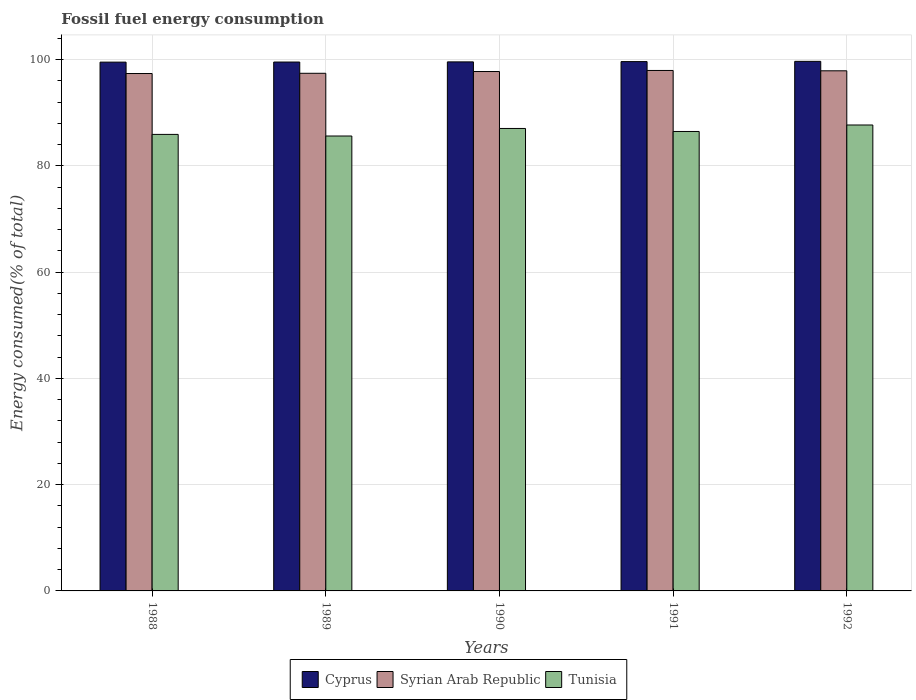How many groups of bars are there?
Your answer should be compact. 5. Are the number of bars per tick equal to the number of legend labels?
Make the answer very short. Yes. How many bars are there on the 5th tick from the left?
Provide a succinct answer. 3. What is the label of the 3rd group of bars from the left?
Keep it short and to the point. 1990. What is the percentage of energy consumed in Cyprus in 1989?
Your answer should be very brief. 99.52. Across all years, what is the maximum percentage of energy consumed in Cyprus?
Make the answer very short. 99.65. Across all years, what is the minimum percentage of energy consumed in Cyprus?
Your answer should be compact. 99.5. What is the total percentage of energy consumed in Tunisia in the graph?
Keep it short and to the point. 432.66. What is the difference between the percentage of energy consumed in Tunisia in 1988 and that in 1992?
Your response must be concise. -1.77. What is the difference between the percentage of energy consumed in Tunisia in 1992 and the percentage of energy consumed in Cyprus in 1991?
Provide a short and direct response. -11.93. What is the average percentage of energy consumed in Cyprus per year?
Keep it short and to the point. 99.57. In the year 1991, what is the difference between the percentage of energy consumed in Cyprus and percentage of energy consumed in Tunisia?
Ensure brevity in your answer.  13.15. What is the ratio of the percentage of energy consumed in Cyprus in 1989 to that in 1990?
Make the answer very short. 1. Is the difference between the percentage of energy consumed in Cyprus in 1991 and 1992 greater than the difference between the percentage of energy consumed in Tunisia in 1991 and 1992?
Keep it short and to the point. Yes. What is the difference between the highest and the second highest percentage of energy consumed in Tunisia?
Provide a short and direct response. 0.65. What is the difference between the highest and the lowest percentage of energy consumed in Tunisia?
Make the answer very short. 2.07. What does the 1st bar from the left in 1992 represents?
Make the answer very short. Cyprus. What does the 3rd bar from the right in 1992 represents?
Your answer should be very brief. Cyprus. Are all the bars in the graph horizontal?
Offer a very short reply. No. What is the difference between two consecutive major ticks on the Y-axis?
Your answer should be very brief. 20. Where does the legend appear in the graph?
Keep it short and to the point. Bottom center. How are the legend labels stacked?
Give a very brief answer. Horizontal. What is the title of the graph?
Offer a terse response. Fossil fuel energy consumption. Does "Vietnam" appear as one of the legend labels in the graph?
Offer a very short reply. No. What is the label or title of the Y-axis?
Provide a short and direct response. Energy consumed(% of total). What is the Energy consumed(% of total) of Cyprus in 1988?
Your response must be concise. 99.5. What is the Energy consumed(% of total) in Syrian Arab Republic in 1988?
Your answer should be very brief. 97.36. What is the Energy consumed(% of total) of Tunisia in 1988?
Your answer should be very brief. 85.9. What is the Energy consumed(% of total) of Cyprus in 1989?
Provide a short and direct response. 99.52. What is the Energy consumed(% of total) of Syrian Arab Republic in 1989?
Provide a succinct answer. 97.4. What is the Energy consumed(% of total) of Tunisia in 1989?
Make the answer very short. 85.6. What is the Energy consumed(% of total) of Cyprus in 1990?
Offer a very short reply. 99.55. What is the Energy consumed(% of total) in Syrian Arab Republic in 1990?
Give a very brief answer. 97.74. What is the Energy consumed(% of total) in Tunisia in 1990?
Your answer should be compact. 87.02. What is the Energy consumed(% of total) of Cyprus in 1991?
Offer a terse response. 99.6. What is the Energy consumed(% of total) in Syrian Arab Republic in 1991?
Offer a very short reply. 97.93. What is the Energy consumed(% of total) in Tunisia in 1991?
Give a very brief answer. 86.45. What is the Energy consumed(% of total) in Cyprus in 1992?
Provide a succinct answer. 99.65. What is the Energy consumed(% of total) of Syrian Arab Republic in 1992?
Make the answer very short. 97.87. What is the Energy consumed(% of total) of Tunisia in 1992?
Offer a terse response. 87.68. Across all years, what is the maximum Energy consumed(% of total) in Cyprus?
Offer a terse response. 99.65. Across all years, what is the maximum Energy consumed(% of total) in Syrian Arab Republic?
Your response must be concise. 97.93. Across all years, what is the maximum Energy consumed(% of total) of Tunisia?
Provide a succinct answer. 87.68. Across all years, what is the minimum Energy consumed(% of total) of Cyprus?
Make the answer very short. 99.5. Across all years, what is the minimum Energy consumed(% of total) of Syrian Arab Republic?
Your answer should be very brief. 97.36. Across all years, what is the minimum Energy consumed(% of total) of Tunisia?
Provide a short and direct response. 85.6. What is the total Energy consumed(% of total) in Cyprus in the graph?
Provide a short and direct response. 497.83. What is the total Energy consumed(% of total) in Syrian Arab Republic in the graph?
Offer a very short reply. 488.31. What is the total Energy consumed(% of total) of Tunisia in the graph?
Offer a terse response. 432.66. What is the difference between the Energy consumed(% of total) of Cyprus in 1988 and that in 1989?
Provide a short and direct response. -0.02. What is the difference between the Energy consumed(% of total) in Syrian Arab Republic in 1988 and that in 1989?
Your answer should be compact. -0.05. What is the difference between the Energy consumed(% of total) in Tunisia in 1988 and that in 1989?
Your answer should be very brief. 0.3. What is the difference between the Energy consumed(% of total) in Cyprus in 1988 and that in 1990?
Your answer should be very brief. -0.05. What is the difference between the Energy consumed(% of total) of Syrian Arab Republic in 1988 and that in 1990?
Offer a terse response. -0.38. What is the difference between the Energy consumed(% of total) in Tunisia in 1988 and that in 1990?
Make the answer very short. -1.12. What is the difference between the Energy consumed(% of total) in Cyprus in 1988 and that in 1991?
Your response must be concise. -0.1. What is the difference between the Energy consumed(% of total) in Syrian Arab Republic in 1988 and that in 1991?
Make the answer very short. -0.58. What is the difference between the Energy consumed(% of total) in Tunisia in 1988 and that in 1991?
Keep it short and to the point. -0.55. What is the difference between the Energy consumed(% of total) of Cyprus in 1988 and that in 1992?
Your answer should be compact. -0.15. What is the difference between the Energy consumed(% of total) of Syrian Arab Republic in 1988 and that in 1992?
Your response must be concise. -0.51. What is the difference between the Energy consumed(% of total) of Tunisia in 1988 and that in 1992?
Keep it short and to the point. -1.77. What is the difference between the Energy consumed(% of total) in Cyprus in 1989 and that in 1990?
Your answer should be compact. -0.03. What is the difference between the Energy consumed(% of total) of Syrian Arab Republic in 1989 and that in 1990?
Your answer should be compact. -0.33. What is the difference between the Energy consumed(% of total) in Tunisia in 1989 and that in 1990?
Ensure brevity in your answer.  -1.42. What is the difference between the Energy consumed(% of total) of Cyprus in 1989 and that in 1991?
Your answer should be compact. -0.08. What is the difference between the Energy consumed(% of total) in Syrian Arab Republic in 1989 and that in 1991?
Your answer should be very brief. -0.53. What is the difference between the Energy consumed(% of total) of Tunisia in 1989 and that in 1991?
Give a very brief answer. -0.85. What is the difference between the Energy consumed(% of total) of Cyprus in 1989 and that in 1992?
Make the answer very short. -0.13. What is the difference between the Energy consumed(% of total) in Syrian Arab Republic in 1989 and that in 1992?
Make the answer very short. -0.47. What is the difference between the Energy consumed(% of total) of Tunisia in 1989 and that in 1992?
Keep it short and to the point. -2.07. What is the difference between the Energy consumed(% of total) in Cyprus in 1990 and that in 1991?
Provide a succinct answer. -0.05. What is the difference between the Energy consumed(% of total) of Syrian Arab Republic in 1990 and that in 1991?
Your answer should be very brief. -0.2. What is the difference between the Energy consumed(% of total) of Tunisia in 1990 and that in 1991?
Keep it short and to the point. 0.57. What is the difference between the Energy consumed(% of total) of Cyprus in 1990 and that in 1992?
Your answer should be very brief. -0.1. What is the difference between the Energy consumed(% of total) in Syrian Arab Republic in 1990 and that in 1992?
Provide a succinct answer. -0.14. What is the difference between the Energy consumed(% of total) of Tunisia in 1990 and that in 1992?
Your answer should be very brief. -0.65. What is the difference between the Energy consumed(% of total) of Cyprus in 1991 and that in 1992?
Your answer should be very brief. -0.05. What is the difference between the Energy consumed(% of total) in Syrian Arab Republic in 1991 and that in 1992?
Give a very brief answer. 0.06. What is the difference between the Energy consumed(% of total) in Tunisia in 1991 and that in 1992?
Give a very brief answer. -1.22. What is the difference between the Energy consumed(% of total) of Cyprus in 1988 and the Energy consumed(% of total) of Syrian Arab Republic in 1989?
Keep it short and to the point. 2.1. What is the difference between the Energy consumed(% of total) in Cyprus in 1988 and the Energy consumed(% of total) in Tunisia in 1989?
Ensure brevity in your answer.  13.9. What is the difference between the Energy consumed(% of total) of Syrian Arab Republic in 1988 and the Energy consumed(% of total) of Tunisia in 1989?
Provide a short and direct response. 11.76. What is the difference between the Energy consumed(% of total) of Cyprus in 1988 and the Energy consumed(% of total) of Syrian Arab Republic in 1990?
Give a very brief answer. 1.77. What is the difference between the Energy consumed(% of total) of Cyprus in 1988 and the Energy consumed(% of total) of Tunisia in 1990?
Offer a terse response. 12.48. What is the difference between the Energy consumed(% of total) of Syrian Arab Republic in 1988 and the Energy consumed(% of total) of Tunisia in 1990?
Offer a terse response. 10.34. What is the difference between the Energy consumed(% of total) in Cyprus in 1988 and the Energy consumed(% of total) in Syrian Arab Republic in 1991?
Provide a short and direct response. 1.57. What is the difference between the Energy consumed(% of total) of Cyprus in 1988 and the Energy consumed(% of total) of Tunisia in 1991?
Your answer should be very brief. 13.05. What is the difference between the Energy consumed(% of total) of Syrian Arab Republic in 1988 and the Energy consumed(% of total) of Tunisia in 1991?
Your answer should be very brief. 10.91. What is the difference between the Energy consumed(% of total) of Cyprus in 1988 and the Energy consumed(% of total) of Syrian Arab Republic in 1992?
Ensure brevity in your answer.  1.63. What is the difference between the Energy consumed(% of total) in Cyprus in 1988 and the Energy consumed(% of total) in Tunisia in 1992?
Offer a terse response. 11.83. What is the difference between the Energy consumed(% of total) of Syrian Arab Republic in 1988 and the Energy consumed(% of total) of Tunisia in 1992?
Give a very brief answer. 9.68. What is the difference between the Energy consumed(% of total) in Cyprus in 1989 and the Energy consumed(% of total) in Syrian Arab Republic in 1990?
Keep it short and to the point. 1.79. What is the difference between the Energy consumed(% of total) in Cyprus in 1989 and the Energy consumed(% of total) in Tunisia in 1990?
Ensure brevity in your answer.  12.5. What is the difference between the Energy consumed(% of total) of Syrian Arab Republic in 1989 and the Energy consumed(% of total) of Tunisia in 1990?
Your response must be concise. 10.38. What is the difference between the Energy consumed(% of total) in Cyprus in 1989 and the Energy consumed(% of total) in Syrian Arab Republic in 1991?
Offer a very short reply. 1.59. What is the difference between the Energy consumed(% of total) of Cyprus in 1989 and the Energy consumed(% of total) of Tunisia in 1991?
Your answer should be very brief. 13.07. What is the difference between the Energy consumed(% of total) of Syrian Arab Republic in 1989 and the Energy consumed(% of total) of Tunisia in 1991?
Keep it short and to the point. 10.95. What is the difference between the Energy consumed(% of total) of Cyprus in 1989 and the Energy consumed(% of total) of Syrian Arab Republic in 1992?
Offer a very short reply. 1.65. What is the difference between the Energy consumed(% of total) of Cyprus in 1989 and the Energy consumed(% of total) of Tunisia in 1992?
Provide a succinct answer. 11.85. What is the difference between the Energy consumed(% of total) in Syrian Arab Republic in 1989 and the Energy consumed(% of total) in Tunisia in 1992?
Your answer should be compact. 9.73. What is the difference between the Energy consumed(% of total) of Cyprus in 1990 and the Energy consumed(% of total) of Syrian Arab Republic in 1991?
Keep it short and to the point. 1.62. What is the difference between the Energy consumed(% of total) of Cyprus in 1990 and the Energy consumed(% of total) of Tunisia in 1991?
Ensure brevity in your answer.  13.1. What is the difference between the Energy consumed(% of total) of Syrian Arab Republic in 1990 and the Energy consumed(% of total) of Tunisia in 1991?
Ensure brevity in your answer.  11.28. What is the difference between the Energy consumed(% of total) of Cyprus in 1990 and the Energy consumed(% of total) of Syrian Arab Republic in 1992?
Give a very brief answer. 1.68. What is the difference between the Energy consumed(% of total) in Cyprus in 1990 and the Energy consumed(% of total) in Tunisia in 1992?
Provide a succinct answer. 11.88. What is the difference between the Energy consumed(% of total) in Syrian Arab Republic in 1990 and the Energy consumed(% of total) in Tunisia in 1992?
Offer a very short reply. 10.06. What is the difference between the Energy consumed(% of total) in Cyprus in 1991 and the Energy consumed(% of total) in Syrian Arab Republic in 1992?
Provide a succinct answer. 1.73. What is the difference between the Energy consumed(% of total) of Cyprus in 1991 and the Energy consumed(% of total) of Tunisia in 1992?
Provide a succinct answer. 11.93. What is the difference between the Energy consumed(% of total) of Syrian Arab Republic in 1991 and the Energy consumed(% of total) of Tunisia in 1992?
Keep it short and to the point. 10.26. What is the average Energy consumed(% of total) of Cyprus per year?
Provide a short and direct response. 99.57. What is the average Energy consumed(% of total) in Syrian Arab Republic per year?
Your answer should be compact. 97.66. What is the average Energy consumed(% of total) of Tunisia per year?
Give a very brief answer. 86.53. In the year 1988, what is the difference between the Energy consumed(% of total) in Cyprus and Energy consumed(% of total) in Syrian Arab Republic?
Give a very brief answer. 2.14. In the year 1988, what is the difference between the Energy consumed(% of total) of Cyprus and Energy consumed(% of total) of Tunisia?
Keep it short and to the point. 13.6. In the year 1988, what is the difference between the Energy consumed(% of total) of Syrian Arab Republic and Energy consumed(% of total) of Tunisia?
Offer a terse response. 11.46. In the year 1989, what is the difference between the Energy consumed(% of total) of Cyprus and Energy consumed(% of total) of Syrian Arab Republic?
Offer a very short reply. 2.12. In the year 1989, what is the difference between the Energy consumed(% of total) in Cyprus and Energy consumed(% of total) in Tunisia?
Provide a succinct answer. 13.92. In the year 1989, what is the difference between the Energy consumed(% of total) of Syrian Arab Republic and Energy consumed(% of total) of Tunisia?
Make the answer very short. 11.8. In the year 1990, what is the difference between the Energy consumed(% of total) of Cyprus and Energy consumed(% of total) of Syrian Arab Republic?
Provide a succinct answer. 1.81. In the year 1990, what is the difference between the Energy consumed(% of total) in Cyprus and Energy consumed(% of total) in Tunisia?
Offer a very short reply. 12.53. In the year 1990, what is the difference between the Energy consumed(% of total) of Syrian Arab Republic and Energy consumed(% of total) of Tunisia?
Provide a succinct answer. 10.71. In the year 1991, what is the difference between the Energy consumed(% of total) in Cyprus and Energy consumed(% of total) in Syrian Arab Republic?
Keep it short and to the point. 1.67. In the year 1991, what is the difference between the Energy consumed(% of total) of Cyprus and Energy consumed(% of total) of Tunisia?
Offer a terse response. 13.15. In the year 1991, what is the difference between the Energy consumed(% of total) of Syrian Arab Republic and Energy consumed(% of total) of Tunisia?
Provide a short and direct response. 11.48. In the year 1992, what is the difference between the Energy consumed(% of total) of Cyprus and Energy consumed(% of total) of Syrian Arab Republic?
Offer a very short reply. 1.78. In the year 1992, what is the difference between the Energy consumed(% of total) of Cyprus and Energy consumed(% of total) of Tunisia?
Provide a short and direct response. 11.97. In the year 1992, what is the difference between the Energy consumed(% of total) of Syrian Arab Republic and Energy consumed(% of total) of Tunisia?
Make the answer very short. 10.2. What is the ratio of the Energy consumed(% of total) in Cyprus in 1988 to that in 1989?
Offer a very short reply. 1. What is the ratio of the Energy consumed(% of total) in Syrian Arab Republic in 1988 to that in 1989?
Offer a very short reply. 1. What is the ratio of the Energy consumed(% of total) in Syrian Arab Republic in 1988 to that in 1990?
Offer a very short reply. 1. What is the ratio of the Energy consumed(% of total) of Tunisia in 1988 to that in 1990?
Your answer should be very brief. 0.99. What is the ratio of the Energy consumed(% of total) in Syrian Arab Republic in 1988 to that in 1991?
Your answer should be very brief. 0.99. What is the ratio of the Energy consumed(% of total) of Syrian Arab Republic in 1988 to that in 1992?
Keep it short and to the point. 0.99. What is the ratio of the Energy consumed(% of total) of Tunisia in 1988 to that in 1992?
Keep it short and to the point. 0.98. What is the ratio of the Energy consumed(% of total) in Syrian Arab Republic in 1989 to that in 1990?
Ensure brevity in your answer.  1. What is the ratio of the Energy consumed(% of total) of Tunisia in 1989 to that in 1990?
Give a very brief answer. 0.98. What is the ratio of the Energy consumed(% of total) in Cyprus in 1989 to that in 1991?
Your answer should be compact. 1. What is the ratio of the Energy consumed(% of total) of Tunisia in 1989 to that in 1991?
Give a very brief answer. 0.99. What is the ratio of the Energy consumed(% of total) in Tunisia in 1989 to that in 1992?
Ensure brevity in your answer.  0.98. What is the ratio of the Energy consumed(% of total) of Tunisia in 1990 to that in 1991?
Make the answer very short. 1.01. What is the ratio of the Energy consumed(% of total) of Cyprus in 1990 to that in 1992?
Your answer should be very brief. 1. What is the ratio of the Energy consumed(% of total) in Syrian Arab Republic in 1990 to that in 1992?
Make the answer very short. 1. What is the ratio of the Energy consumed(% of total) of Cyprus in 1991 to that in 1992?
Ensure brevity in your answer.  1. What is the ratio of the Energy consumed(% of total) of Syrian Arab Republic in 1991 to that in 1992?
Your answer should be compact. 1. What is the ratio of the Energy consumed(% of total) in Tunisia in 1991 to that in 1992?
Keep it short and to the point. 0.99. What is the difference between the highest and the second highest Energy consumed(% of total) in Cyprus?
Your answer should be very brief. 0.05. What is the difference between the highest and the second highest Energy consumed(% of total) of Syrian Arab Republic?
Offer a very short reply. 0.06. What is the difference between the highest and the second highest Energy consumed(% of total) of Tunisia?
Make the answer very short. 0.65. What is the difference between the highest and the lowest Energy consumed(% of total) of Cyprus?
Your answer should be compact. 0.15. What is the difference between the highest and the lowest Energy consumed(% of total) of Syrian Arab Republic?
Provide a succinct answer. 0.58. What is the difference between the highest and the lowest Energy consumed(% of total) in Tunisia?
Give a very brief answer. 2.07. 